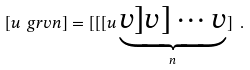<formula> <loc_0><loc_0><loc_500><loc_500>[ u \ g r { v } { n } ] = [ [ [ u \underbrace { v ] v ] \cdots v } _ { n } ] \ .</formula> 